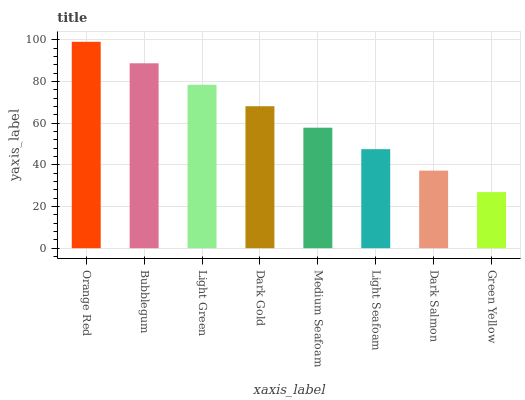Is Bubblegum the minimum?
Answer yes or no. No. Is Bubblegum the maximum?
Answer yes or no. No. Is Orange Red greater than Bubblegum?
Answer yes or no. Yes. Is Bubblegum less than Orange Red?
Answer yes or no. Yes. Is Bubblegum greater than Orange Red?
Answer yes or no. No. Is Orange Red less than Bubblegum?
Answer yes or no. No. Is Dark Gold the high median?
Answer yes or no. Yes. Is Medium Seafoam the low median?
Answer yes or no. Yes. Is Bubblegum the high median?
Answer yes or no. No. Is Green Yellow the low median?
Answer yes or no. No. 